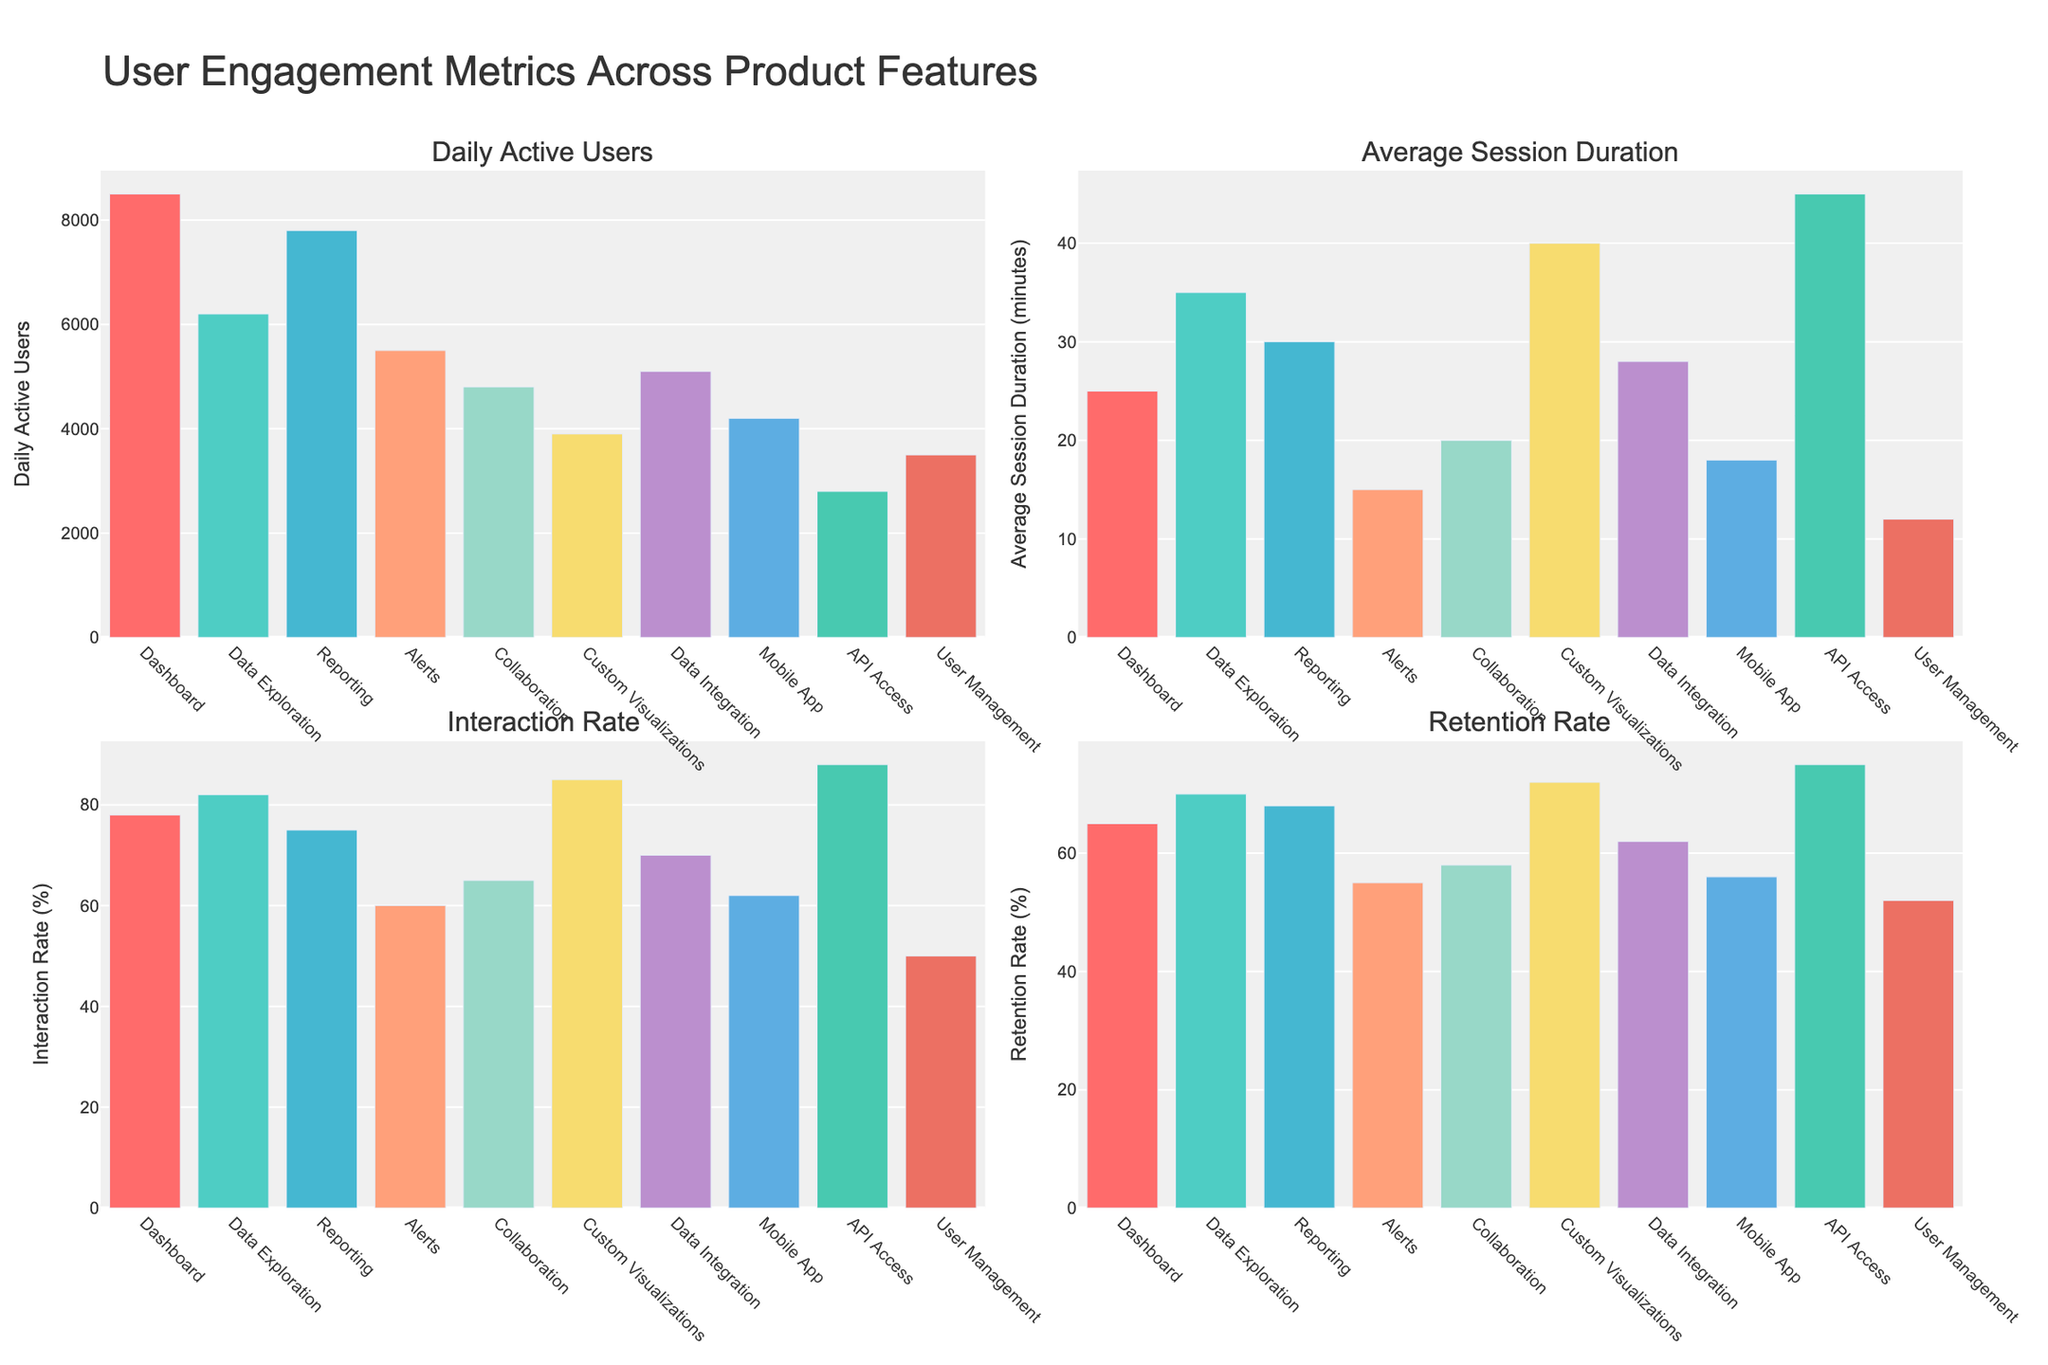What feature has the highest number of daily active users? The Dashboard feature has the highest bar in the "Daily Active Users" subplot, indicating the highest number of daily active users.
Answer: Dashboard Which feature has the lowest retention rate? The User Management feature has the shortest bar in the "Retention Rate" subplot, indicating the lowest retention rate.
Answer: User Management What is the sum of daily active users for the Reporting and Alerts features? The number of daily active users for Reporting is 7800, and for Alerts, it is 5500. The sum is 7800 + 5500 = 13300.
Answer: 13300 Which features have an average session duration longer than 30 minutes? The features with bars taller than 30 minutes in the "Average Session Duration" subplot are Data Exploration, Custom Visualizations, and API Access.
Answer: Data Exploration, Custom Visualizations, API Access Compare the interaction rate of the Collaboration feature to that of the Data Integration feature. Which is higher? The Collaboration feature has an interaction rate of 65%, and Data Integration has an interaction rate of 70%. Data Integration is higher.
Answer: Data Integration What is the difference between the highest and lowest interaction rates? The highest interaction rate is for API Access at 88%, and the lowest is for User Management at 50%. The difference is 88% - 50% = 38%.
Answer: 38% How do the colors vary in the bar chart, and does any color dominate any subplot? Each feature is represented by a unique color across all subplots. No specific color dominates any particular subplot; colors are evenly distributed.
Answer: Evenly distributed What is the average retention rate for Dashboard, Reporting, and Mobile App features? The retention rates are 65% for Dashboard, 68% for Reporting, and 56% for the Mobile App. The average is (65% + 68% + 56%) / 3 = 63%.
Answer: 63% Find the feature with the second highest average session duration. The API Access feature has the highest average session duration of 45 minutes. The second highest is Custom Visualizations with 40 minutes.
Answer: Custom Visualizations Which feature has the closest daily active users to the Data Integration feature? Data Integration has 5100 daily active users. Mobile App has 4200 daily active users, which is the closest.
Answer: Mobile App 